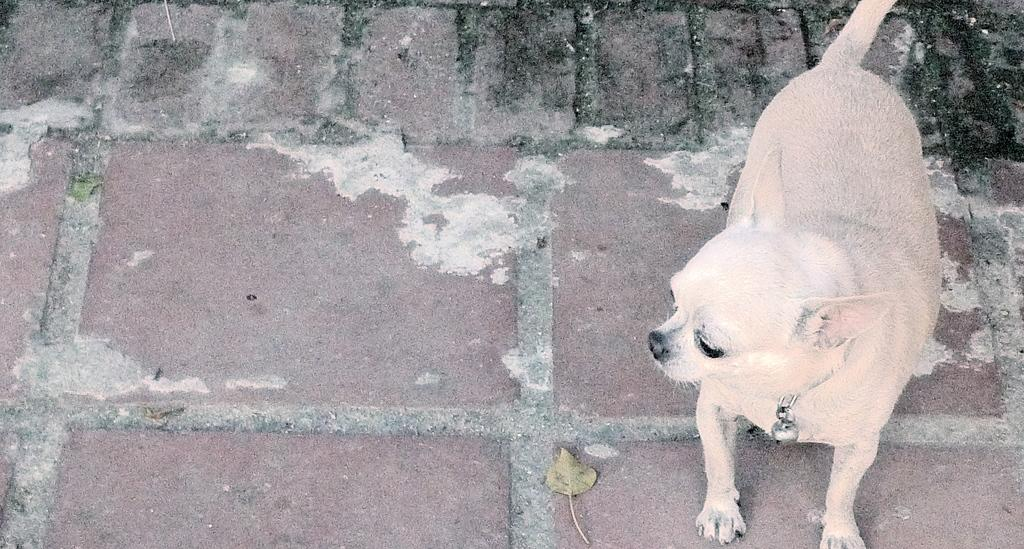What type of creature can be seen in the image? There is an animal in the image. Can you describe the animal's position in the image? The animal is standing on the ground. What else can be seen on the ground in the image? There are leaves on the ground in the image. How many kittens are smashing the leaves in the image? There are no kittens present in the image, and the animal is not smashing the leaves. 